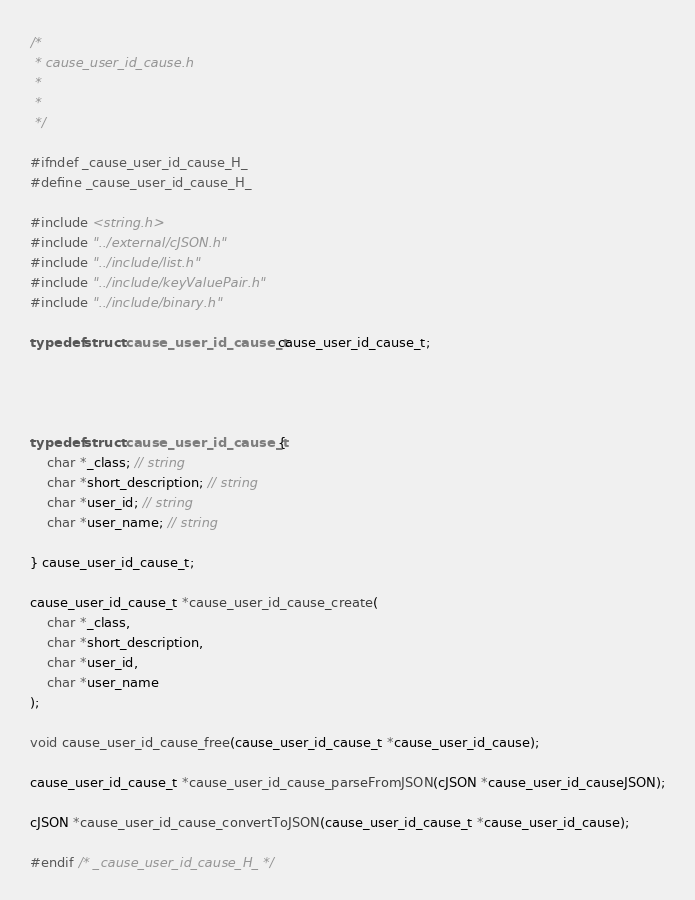<code> <loc_0><loc_0><loc_500><loc_500><_C_>/*
 * cause_user_id_cause.h
 *
 * 
 */

#ifndef _cause_user_id_cause_H_
#define _cause_user_id_cause_H_

#include <string.h>
#include "../external/cJSON.h"
#include "../include/list.h"
#include "../include/keyValuePair.h"
#include "../include/binary.h"

typedef struct cause_user_id_cause_t cause_user_id_cause_t;




typedef struct cause_user_id_cause_t {
    char *_class; // string
    char *short_description; // string
    char *user_id; // string
    char *user_name; // string

} cause_user_id_cause_t;

cause_user_id_cause_t *cause_user_id_cause_create(
    char *_class,
    char *short_description,
    char *user_id,
    char *user_name
);

void cause_user_id_cause_free(cause_user_id_cause_t *cause_user_id_cause);

cause_user_id_cause_t *cause_user_id_cause_parseFromJSON(cJSON *cause_user_id_causeJSON);

cJSON *cause_user_id_cause_convertToJSON(cause_user_id_cause_t *cause_user_id_cause);

#endif /* _cause_user_id_cause_H_ */

</code> 